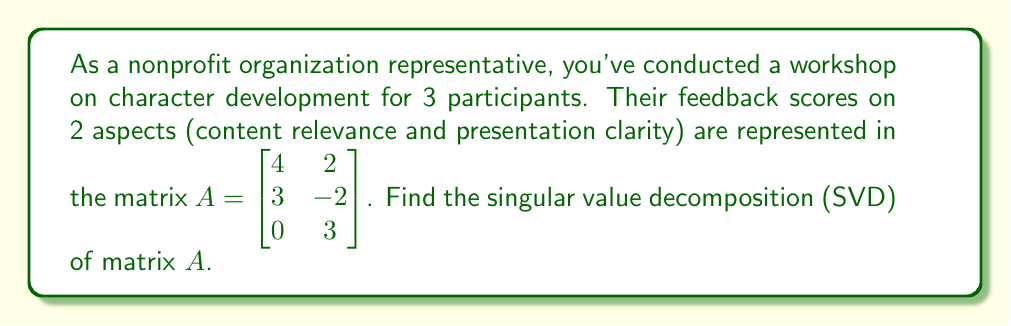Could you help me with this problem? To find the singular value decomposition of matrix $A$, we need to follow these steps:

1) First, calculate $A^TA$:
   $$A^TA = \begin{bmatrix} 4 & 3 & 0 \\ 2 & -2 & 3 \end{bmatrix} \begin{bmatrix} 4 & 2 \\ 3 & -2 \\ 0 & 3 \end{bmatrix} = \begin{bmatrix} 25 & 2 \\ 2 & 17 \end{bmatrix}$$

2) Find the eigenvalues of $A^TA$:
   $\det(A^TA - \lambda I) = \begin{vmatrix} 25-\lambda & 2 \\ 2 & 17-\lambda \end{vmatrix} = (25-\lambda)(17-\lambda) - 4 = \lambda^2 - 42\lambda + 421 = 0$
   Solving this equation gives $\lambda_1 = 26$ and $\lambda_2 = 16$

3) The singular values are the square roots of these eigenvalues:
   $\sigma_1 = \sqrt{26}$ and $\sigma_2 = 4$

4) Find the eigenvectors of $A^TA$ (right singular vectors):
   For $\lambda_1 = 26$: $(A^TA - 26I)v = 0$ gives $v_1 = \begin{bmatrix} 2/\sqrt{5} \\ 1/\sqrt{5} \end{bmatrix}$
   For $\lambda_2 = 16$: $(A^TA - 16I)v = 0$ gives $v_2 = \begin{bmatrix} -1/\sqrt{5} \\ 2/\sqrt{5} \end{bmatrix}$

5) Calculate the left singular vectors:
   $u_1 = \frac{1}{\sigma_1}Av_1 = \frac{1}{\sqrt{26}}\begin{bmatrix} 10/\sqrt{5} \\ 4/\sqrt{5} \\ 3/\sqrt{5} \end{bmatrix}$
   $u_2 = \frac{1}{\sigma_2}Av_2 = \frac{1}{4}\begin{bmatrix} 0 \\ -5/\sqrt{5} \\ 6/\sqrt{5} \end{bmatrix}$

6) The third left singular vector is orthogonal to $u_1$ and $u_2$:
   $u_3 = \begin{bmatrix} 3/\sqrt{10} \\ -1/\sqrt{10} \\ -2/\sqrt{10} \end{bmatrix}$

Therefore, the SVD of $A$ is $A = U\Sigma V^T$, where:
$U = \begin{bmatrix} 10/\sqrt{130} & 0 & 3/\sqrt{10} \\ 4/\sqrt{130} & -5/(4\sqrt{5}) & -1/\sqrt{10} \\ 3/\sqrt{130} & 3/(2\sqrt{5}) & -2/\sqrt{10} \end{bmatrix}$

$\Sigma = \begin{bmatrix} \sqrt{26} & 0 \\ 0 & 4 \\ 0 & 0 \end{bmatrix}$

$V = \begin{bmatrix} 2/\sqrt{5} & -1/\sqrt{5} \\ 1/\sqrt{5} & 2/\sqrt{5} \end{bmatrix}$
Answer: $A = U\Sigma V^T$, where
$U = \begin{bmatrix} 10/\sqrt{130} & 0 & 3/\sqrt{10} \\ 4/\sqrt{130} & -5/(4\sqrt{5}) & -1/\sqrt{10} \\ 3/\sqrt{130} & 3/(2\sqrt{5}) & -2/\sqrt{10} \end{bmatrix}$,
$\Sigma = \begin{bmatrix} \sqrt{26} & 0 \\ 0 & 4 \\ 0 & 0 \end{bmatrix}$,
$V = \begin{bmatrix} 2/\sqrt{5} & -1/\sqrt{5} \\ 1/\sqrt{5} & 2/\sqrt{5} \end{bmatrix}$ 